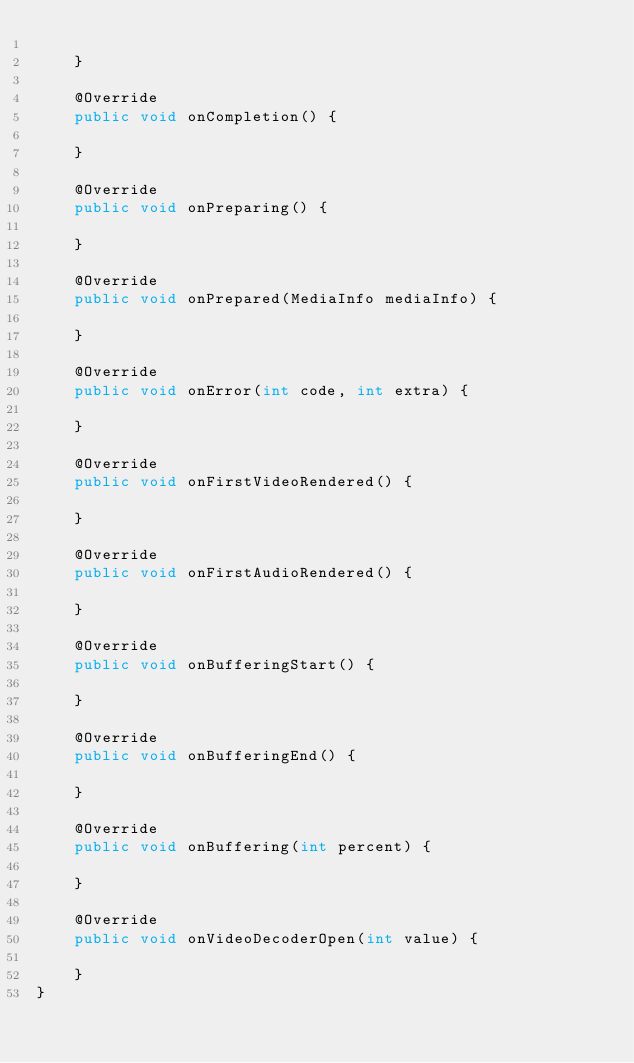Convert code to text. <code><loc_0><loc_0><loc_500><loc_500><_Java_>
    }

    @Override
    public void onCompletion() {

    }

    @Override
    public void onPreparing() {

    }

    @Override
    public void onPrepared(MediaInfo mediaInfo) {

    }

    @Override
    public void onError(int code, int extra) {

    }

    @Override
    public void onFirstVideoRendered() {

    }

    @Override
    public void onFirstAudioRendered() {

    }

    @Override
    public void onBufferingStart() {

    }

    @Override
    public void onBufferingEnd() {

    }

    @Override
    public void onBuffering(int percent) {

    }

    @Override
    public void onVideoDecoderOpen(int value) {

    }
}
</code> 